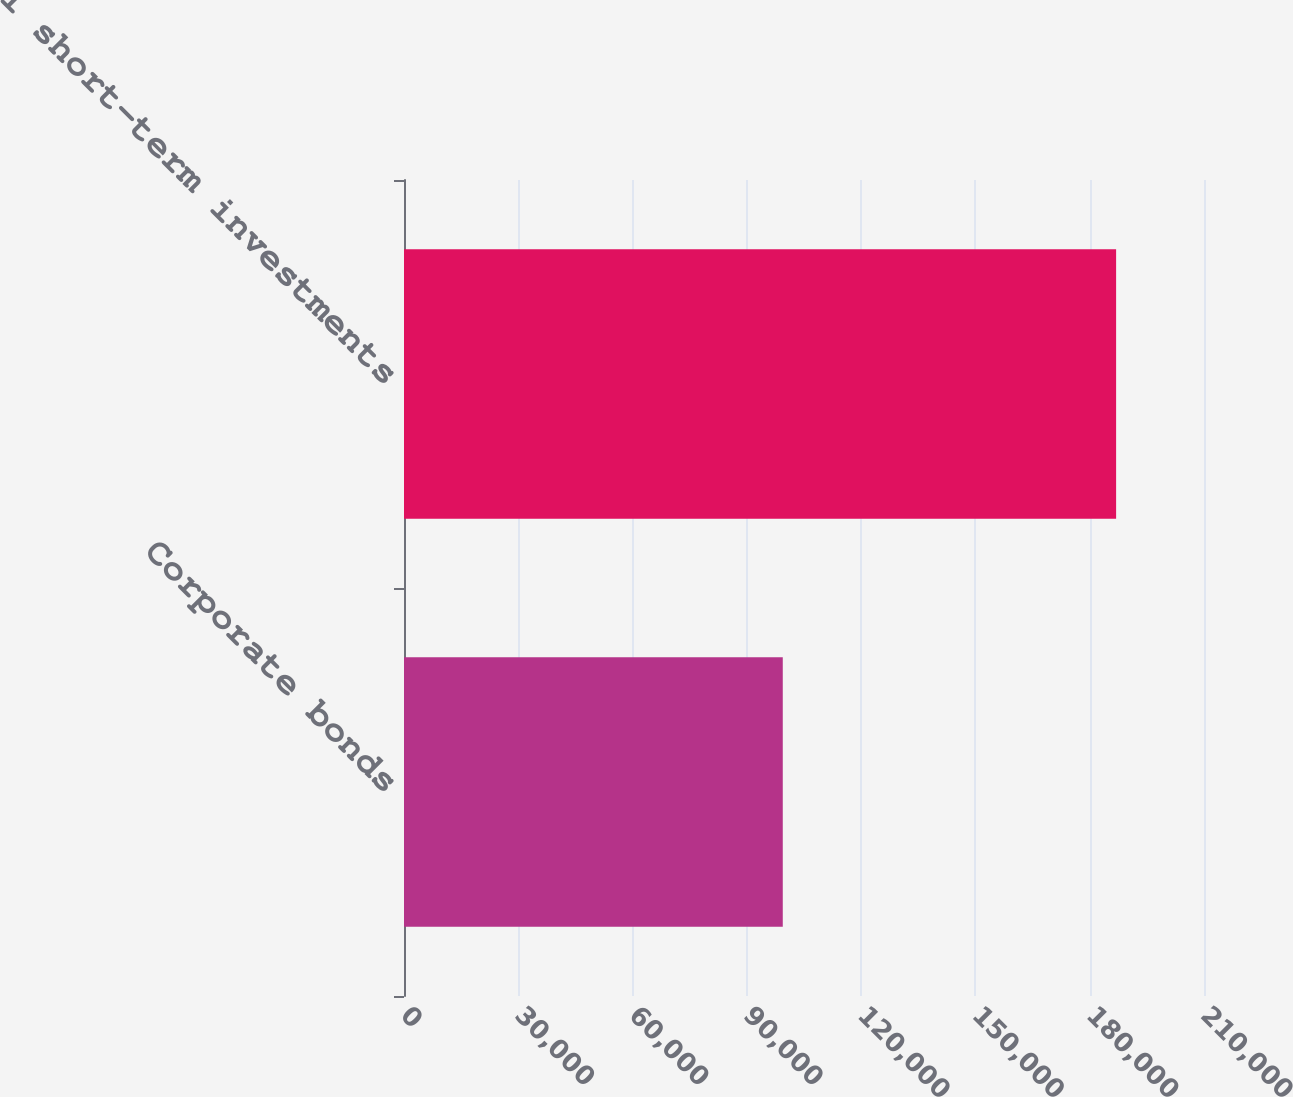<chart> <loc_0><loc_0><loc_500><loc_500><bar_chart><fcel>Corporate bonds<fcel>Total short-term investments<nl><fcel>99429<fcel>186929<nl></chart> 